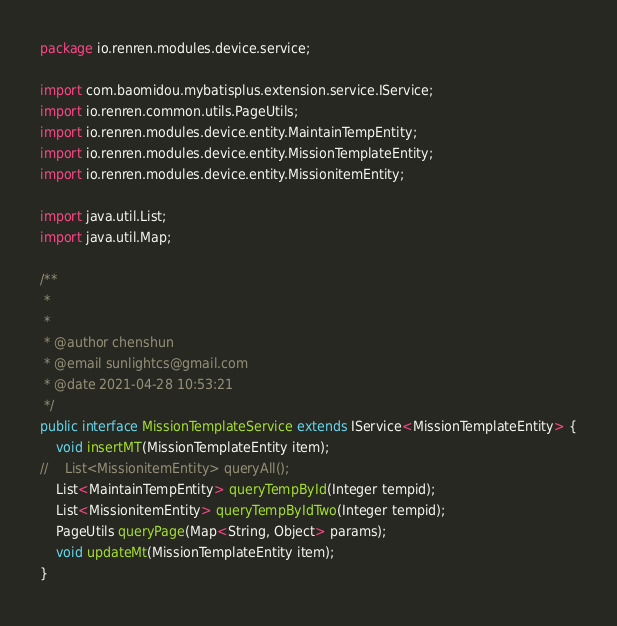<code> <loc_0><loc_0><loc_500><loc_500><_Java_>package io.renren.modules.device.service;

import com.baomidou.mybatisplus.extension.service.IService;
import io.renren.common.utils.PageUtils;
import io.renren.modules.device.entity.MaintainTempEntity;
import io.renren.modules.device.entity.MissionTemplateEntity;
import io.renren.modules.device.entity.MissionitemEntity;

import java.util.List;
import java.util.Map;

/**
 * 
 *
 * @author chenshun
 * @email sunlightcs@gmail.com
 * @date 2021-04-28 10:53:21
 */
public interface MissionTemplateService extends IService<MissionTemplateEntity> {
    void insertMT(MissionTemplateEntity item);
//    List<MissionitemEntity> queryAll();
    List<MaintainTempEntity> queryTempById(Integer tempid);
    List<MissionitemEntity> queryTempByIdTwo(Integer tempid);
    PageUtils queryPage(Map<String, Object> params);
    void updateMt(MissionTemplateEntity item);
}

</code> 